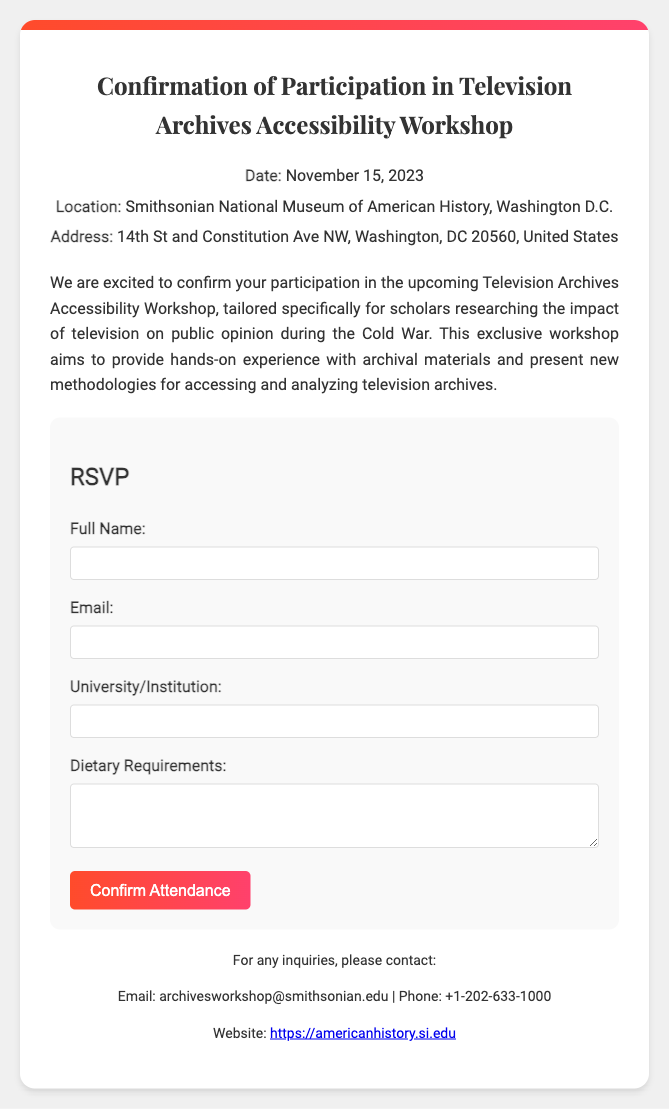what is the date of the workshop? The date of the workshop is explicitly mentioned in the card.
Answer: November 15, 2023 what is the location of the workshop? The location is provided in a dedicated section in the document.
Answer: Smithsonian National Museum of American History, Washington D.C what is the address of the event? The address is clearly listed along with the location details.
Answer: 14th St and Constitution Ave NW, Washington, DC 20560, United States what is the purpose of the workshop? The purpose of the workshop is stated in the description, aimed at scholars researching a specific topic.
Answer: provide hands-on experience with archival materials who should you contact for inquiries? The contact information is provided in the document for any inquiries regarding the workshop.
Answer: archivesworkshop@smithsonian.edu what is required for RSVP submission? The form specifies what details are required to confirm attendance.
Answer: Full Name and Email how can participants confirm their attendance? The document includes a form and a button for participants to confirm their attendance.
Answer: Confirm Attendance button what type of dietary preferences can be mentioned? The dietary preferences can be categorized or noted in a specific section of the form.
Answer: Dietary Requirements 